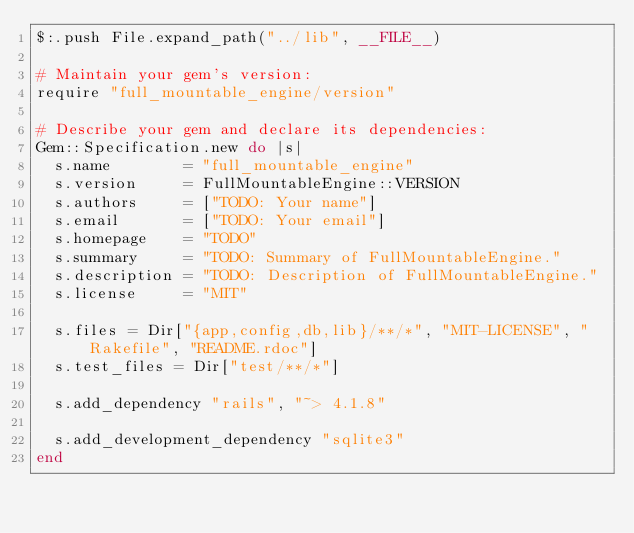<code> <loc_0><loc_0><loc_500><loc_500><_Ruby_>$:.push File.expand_path("../lib", __FILE__)

# Maintain your gem's version:
require "full_mountable_engine/version"

# Describe your gem and declare its dependencies:
Gem::Specification.new do |s|
  s.name        = "full_mountable_engine"
  s.version     = FullMountableEngine::VERSION
  s.authors     = ["TODO: Your name"]
  s.email       = ["TODO: Your email"]
  s.homepage    = "TODO"
  s.summary     = "TODO: Summary of FullMountableEngine."
  s.description = "TODO: Description of FullMountableEngine."
  s.license     = "MIT"

  s.files = Dir["{app,config,db,lib}/**/*", "MIT-LICENSE", "Rakefile", "README.rdoc"]
  s.test_files = Dir["test/**/*"]

  s.add_dependency "rails", "~> 4.1.8"

  s.add_development_dependency "sqlite3"
end
</code> 